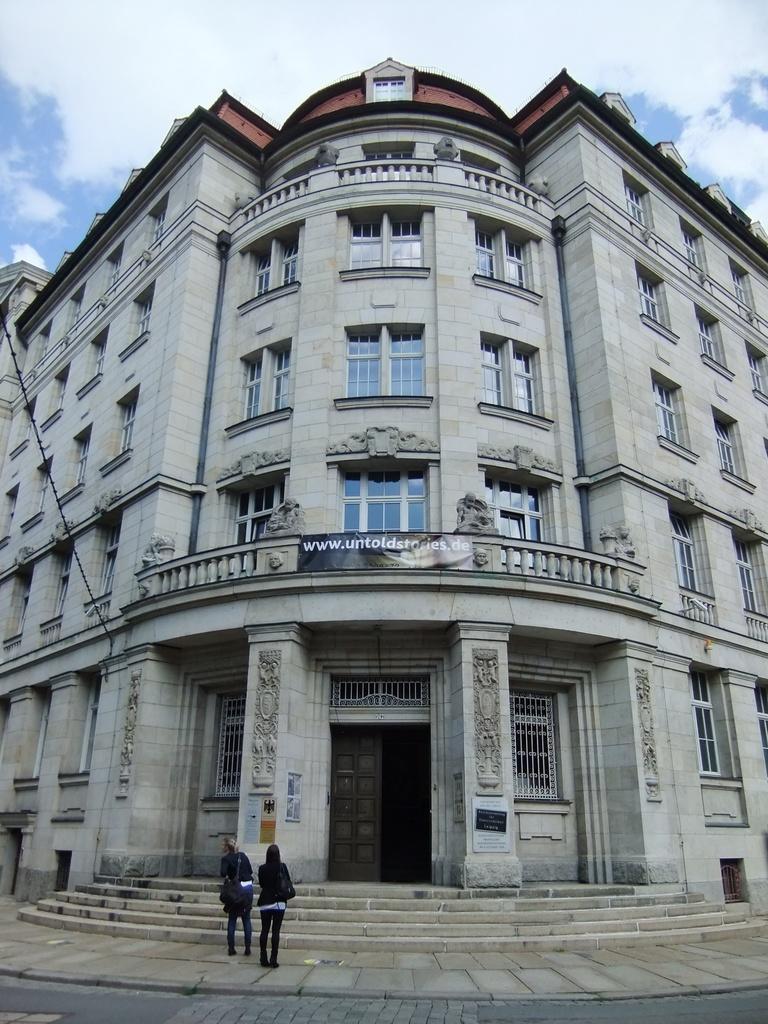How would you summarize this image in a sentence or two? In this image I can see the ground, two persons standing on the ground, few stairs and a huge building. I can see few windows of the building and in the background I can see the sky. 